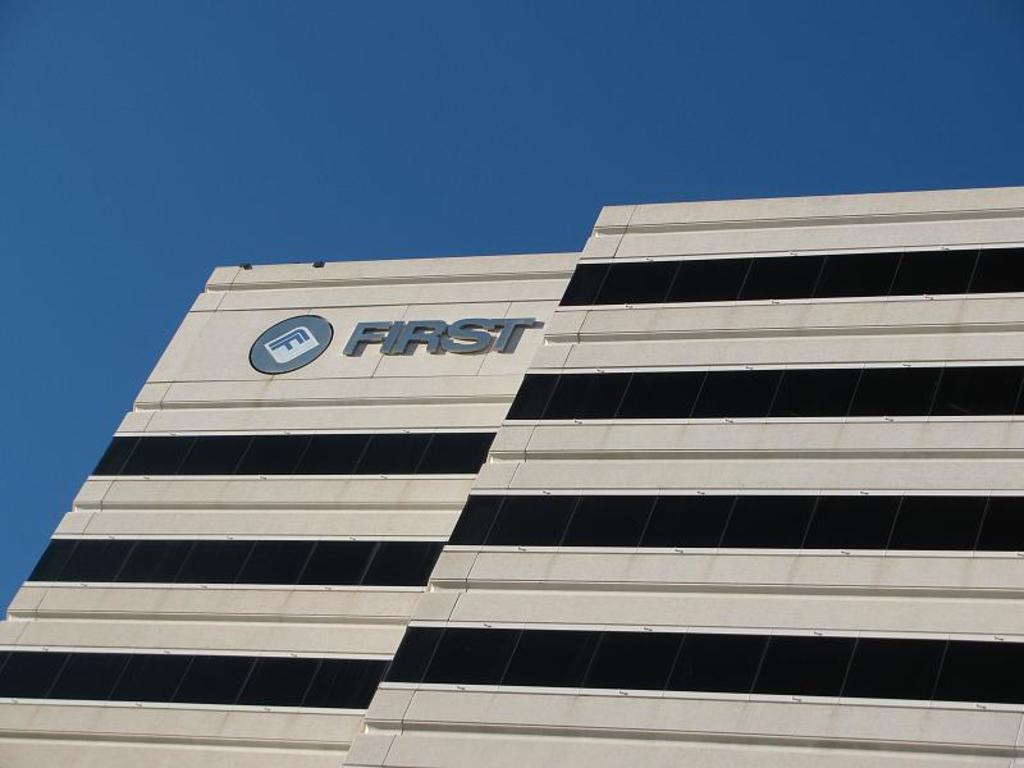What type of structure is visible in the image? There is a building in the image. What type of sound can be heard coming from the building in the image? There is no information about any sounds in the image, so it is not possible to determine what, if any, sounds might be heard. 